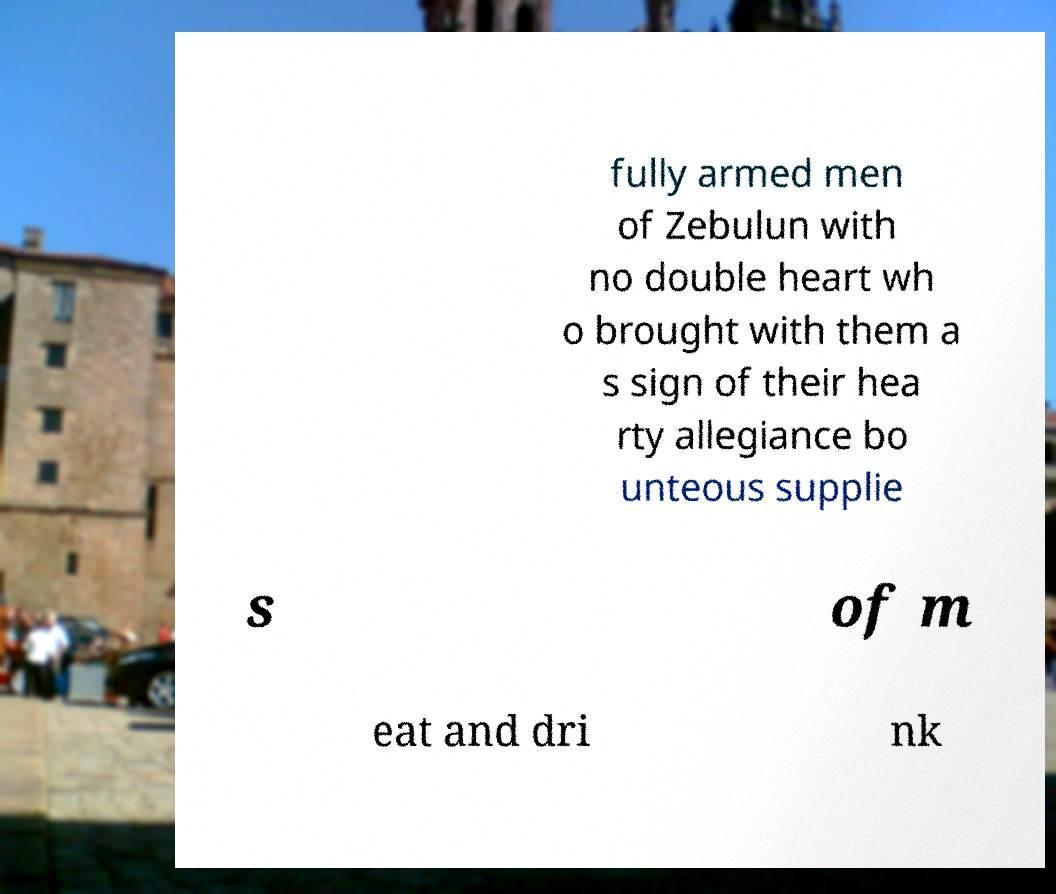Could you extract and type out the text from this image? fully armed men of Zebulun with no double heart wh o brought with them a s sign of their hea rty allegiance bo unteous supplie s of m eat and dri nk 